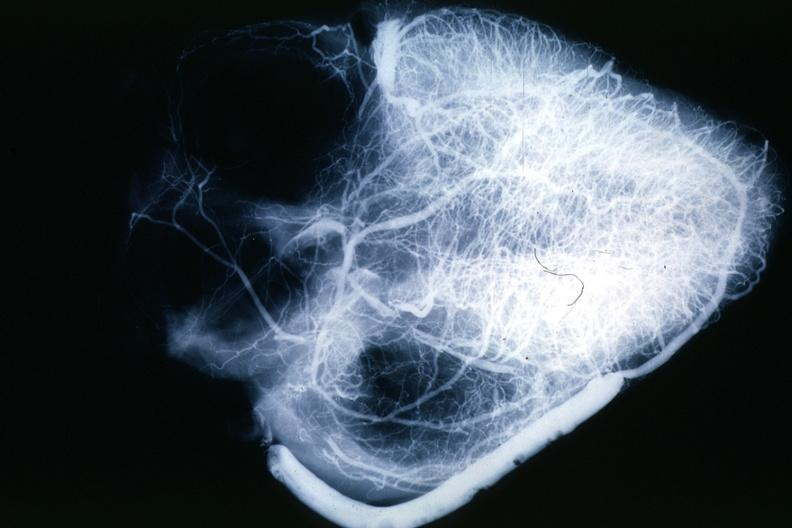where is this from?
Answer the question using a single word or phrase. Heart 